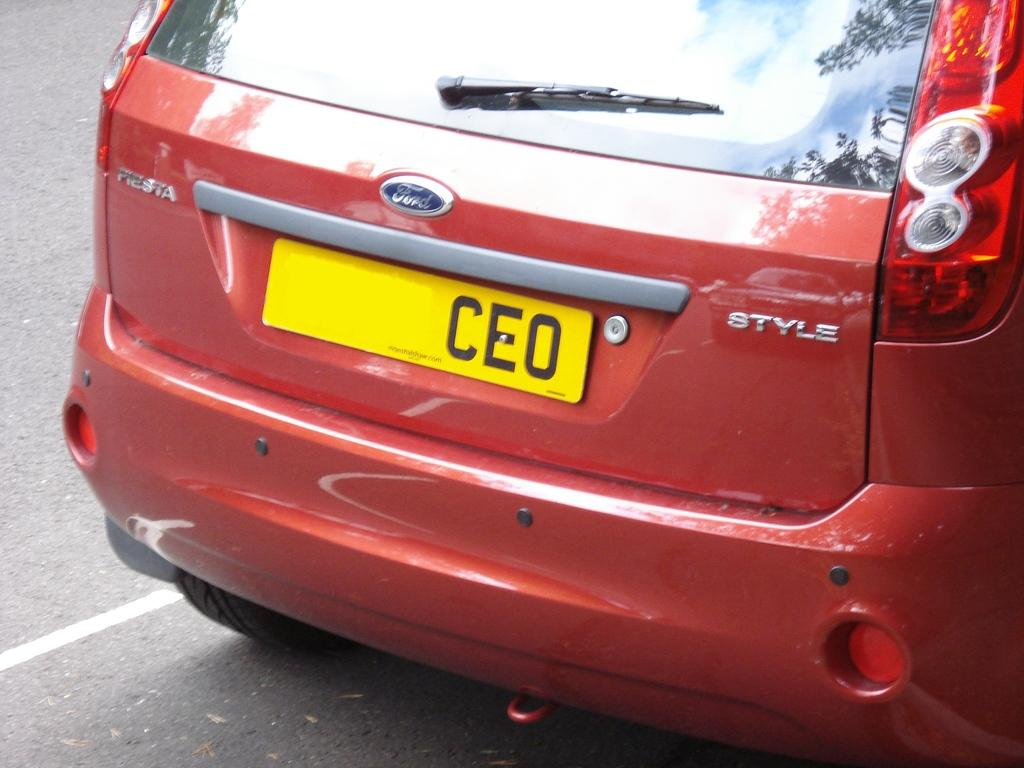<image>
Render a clear and concise summary of the photo. A red ford Style with the license plate CEO. 